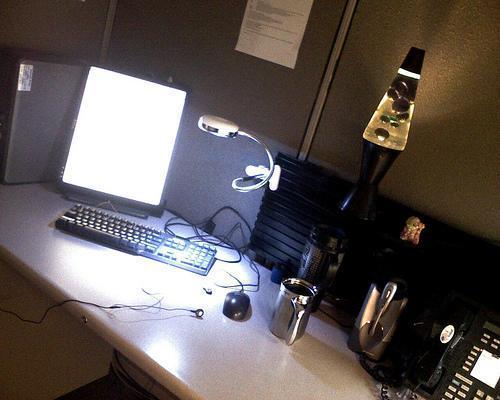How many cups can be seen?
Give a very brief answer. 2. 